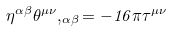<formula> <loc_0><loc_0><loc_500><loc_500>\eta ^ { \alpha \beta } \theta ^ { \mu \nu } , _ { \alpha \beta } = - 1 6 \pi \tau ^ { \mu \nu }</formula> 